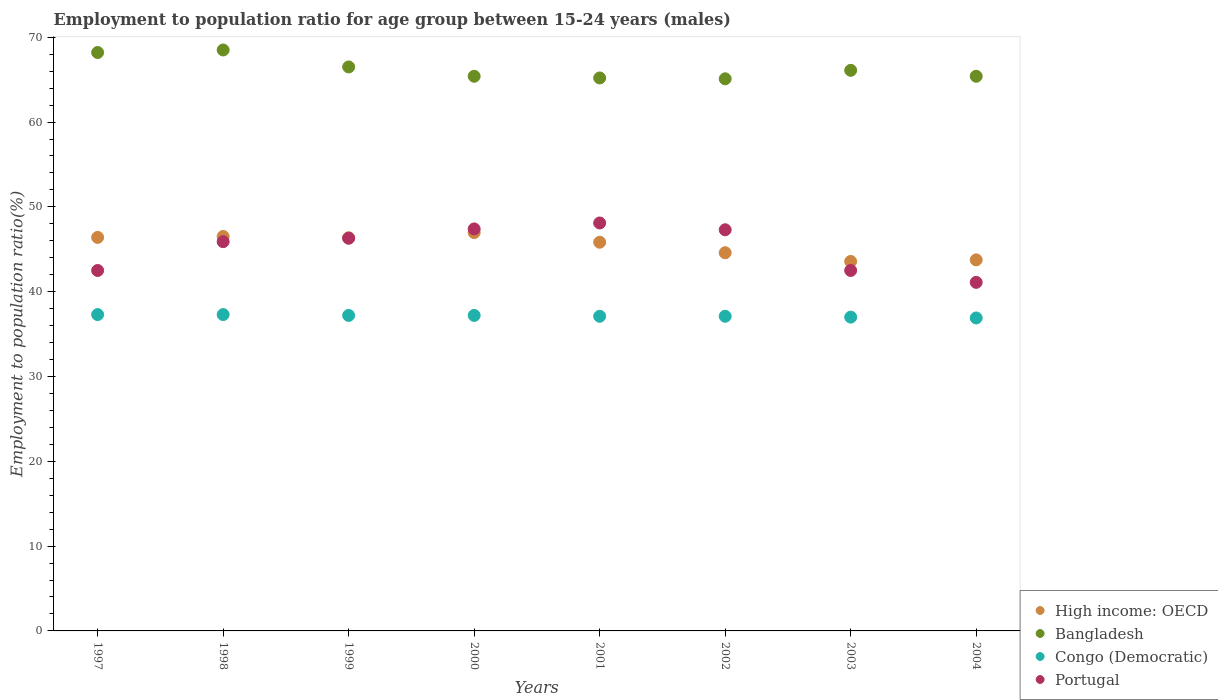What is the employment to population ratio in High income: OECD in 2004?
Your answer should be compact. 43.75. Across all years, what is the maximum employment to population ratio in Portugal?
Keep it short and to the point. 48.1. Across all years, what is the minimum employment to population ratio in Bangladesh?
Offer a very short reply. 65.1. What is the total employment to population ratio in Congo (Democratic) in the graph?
Your answer should be compact. 297.1. What is the difference between the employment to population ratio in Bangladesh in 2002 and that in 2004?
Your response must be concise. -0.3. What is the difference between the employment to population ratio in Portugal in 2002 and the employment to population ratio in High income: OECD in 1997?
Provide a short and direct response. 0.9. What is the average employment to population ratio in High income: OECD per year?
Provide a short and direct response. 45.5. In the year 2000, what is the difference between the employment to population ratio in High income: OECD and employment to population ratio in Congo (Democratic)?
Your answer should be very brief. 9.77. In how many years, is the employment to population ratio in Portugal greater than 26 %?
Provide a succinct answer. 8. What is the ratio of the employment to population ratio in Portugal in 1997 to that in 2000?
Your response must be concise. 0.9. What is the difference between the highest and the second highest employment to population ratio in Portugal?
Your answer should be compact. 0.7. What is the difference between the highest and the lowest employment to population ratio in Bangladesh?
Your answer should be compact. 3.4. Is the sum of the employment to population ratio in High income: OECD in 1998 and 1999 greater than the maximum employment to population ratio in Bangladesh across all years?
Your answer should be very brief. Yes. Does the employment to population ratio in High income: OECD monotonically increase over the years?
Provide a short and direct response. No. Is the employment to population ratio in High income: OECD strictly greater than the employment to population ratio in Bangladesh over the years?
Make the answer very short. No. How many years are there in the graph?
Ensure brevity in your answer.  8. What is the difference between two consecutive major ticks on the Y-axis?
Your answer should be compact. 10. Are the values on the major ticks of Y-axis written in scientific E-notation?
Offer a very short reply. No. Does the graph contain grids?
Your answer should be very brief. No. Where does the legend appear in the graph?
Keep it short and to the point. Bottom right. What is the title of the graph?
Make the answer very short. Employment to population ratio for age group between 15-24 years (males). What is the label or title of the Y-axis?
Your response must be concise. Employment to population ratio(%). What is the Employment to population ratio(%) in High income: OECD in 1997?
Offer a very short reply. 46.4. What is the Employment to population ratio(%) in Bangladesh in 1997?
Offer a very short reply. 68.2. What is the Employment to population ratio(%) in Congo (Democratic) in 1997?
Give a very brief answer. 37.3. What is the Employment to population ratio(%) in Portugal in 1997?
Your response must be concise. 42.5. What is the Employment to population ratio(%) in High income: OECD in 1998?
Ensure brevity in your answer.  46.51. What is the Employment to population ratio(%) in Bangladesh in 1998?
Offer a very short reply. 68.5. What is the Employment to population ratio(%) in Congo (Democratic) in 1998?
Your answer should be compact. 37.3. What is the Employment to population ratio(%) of Portugal in 1998?
Offer a terse response. 45.9. What is the Employment to population ratio(%) of High income: OECD in 1999?
Give a very brief answer. 46.36. What is the Employment to population ratio(%) in Bangladesh in 1999?
Offer a terse response. 66.5. What is the Employment to population ratio(%) in Congo (Democratic) in 1999?
Offer a very short reply. 37.2. What is the Employment to population ratio(%) of Portugal in 1999?
Your answer should be compact. 46.3. What is the Employment to population ratio(%) in High income: OECD in 2000?
Give a very brief answer. 46.97. What is the Employment to population ratio(%) of Bangladesh in 2000?
Give a very brief answer. 65.4. What is the Employment to population ratio(%) in Congo (Democratic) in 2000?
Keep it short and to the point. 37.2. What is the Employment to population ratio(%) in Portugal in 2000?
Your response must be concise. 47.4. What is the Employment to population ratio(%) in High income: OECD in 2001?
Your answer should be compact. 45.83. What is the Employment to population ratio(%) in Bangladesh in 2001?
Your answer should be very brief. 65.2. What is the Employment to population ratio(%) of Congo (Democratic) in 2001?
Your response must be concise. 37.1. What is the Employment to population ratio(%) of Portugal in 2001?
Your answer should be compact. 48.1. What is the Employment to population ratio(%) of High income: OECD in 2002?
Your response must be concise. 44.59. What is the Employment to population ratio(%) of Bangladesh in 2002?
Ensure brevity in your answer.  65.1. What is the Employment to population ratio(%) of Congo (Democratic) in 2002?
Offer a very short reply. 37.1. What is the Employment to population ratio(%) of Portugal in 2002?
Provide a short and direct response. 47.3. What is the Employment to population ratio(%) of High income: OECD in 2003?
Provide a succinct answer. 43.56. What is the Employment to population ratio(%) in Bangladesh in 2003?
Keep it short and to the point. 66.1. What is the Employment to population ratio(%) of Congo (Democratic) in 2003?
Ensure brevity in your answer.  37. What is the Employment to population ratio(%) in Portugal in 2003?
Make the answer very short. 42.5. What is the Employment to population ratio(%) of High income: OECD in 2004?
Give a very brief answer. 43.75. What is the Employment to population ratio(%) of Bangladesh in 2004?
Make the answer very short. 65.4. What is the Employment to population ratio(%) of Congo (Democratic) in 2004?
Provide a succinct answer. 36.9. What is the Employment to population ratio(%) of Portugal in 2004?
Provide a succinct answer. 41.1. Across all years, what is the maximum Employment to population ratio(%) in High income: OECD?
Provide a short and direct response. 46.97. Across all years, what is the maximum Employment to population ratio(%) of Bangladesh?
Make the answer very short. 68.5. Across all years, what is the maximum Employment to population ratio(%) of Congo (Democratic)?
Ensure brevity in your answer.  37.3. Across all years, what is the maximum Employment to population ratio(%) in Portugal?
Your response must be concise. 48.1. Across all years, what is the minimum Employment to population ratio(%) of High income: OECD?
Provide a short and direct response. 43.56. Across all years, what is the minimum Employment to population ratio(%) of Bangladesh?
Your answer should be compact. 65.1. Across all years, what is the minimum Employment to population ratio(%) in Congo (Democratic)?
Provide a succinct answer. 36.9. Across all years, what is the minimum Employment to population ratio(%) of Portugal?
Ensure brevity in your answer.  41.1. What is the total Employment to population ratio(%) in High income: OECD in the graph?
Ensure brevity in your answer.  363.98. What is the total Employment to population ratio(%) of Bangladesh in the graph?
Provide a short and direct response. 530.4. What is the total Employment to population ratio(%) in Congo (Democratic) in the graph?
Keep it short and to the point. 297.1. What is the total Employment to population ratio(%) in Portugal in the graph?
Your response must be concise. 361.1. What is the difference between the Employment to population ratio(%) in High income: OECD in 1997 and that in 1998?
Make the answer very short. -0.11. What is the difference between the Employment to population ratio(%) in Bangladesh in 1997 and that in 1998?
Provide a succinct answer. -0.3. What is the difference between the Employment to population ratio(%) in Congo (Democratic) in 1997 and that in 1998?
Provide a short and direct response. 0. What is the difference between the Employment to population ratio(%) in High income: OECD in 1997 and that in 1999?
Offer a very short reply. 0.04. What is the difference between the Employment to population ratio(%) in Congo (Democratic) in 1997 and that in 1999?
Your response must be concise. 0.1. What is the difference between the Employment to population ratio(%) in High income: OECD in 1997 and that in 2000?
Offer a very short reply. -0.57. What is the difference between the Employment to population ratio(%) of Bangladesh in 1997 and that in 2000?
Provide a succinct answer. 2.8. What is the difference between the Employment to population ratio(%) in Portugal in 1997 and that in 2000?
Ensure brevity in your answer.  -4.9. What is the difference between the Employment to population ratio(%) in High income: OECD in 1997 and that in 2001?
Your answer should be compact. 0.57. What is the difference between the Employment to population ratio(%) in Bangladesh in 1997 and that in 2001?
Your response must be concise. 3. What is the difference between the Employment to population ratio(%) in Congo (Democratic) in 1997 and that in 2001?
Your answer should be very brief. 0.2. What is the difference between the Employment to population ratio(%) of Portugal in 1997 and that in 2001?
Your answer should be compact. -5.6. What is the difference between the Employment to population ratio(%) of High income: OECD in 1997 and that in 2002?
Give a very brief answer. 1.81. What is the difference between the Employment to population ratio(%) of Bangladesh in 1997 and that in 2002?
Provide a short and direct response. 3.1. What is the difference between the Employment to population ratio(%) of Congo (Democratic) in 1997 and that in 2002?
Provide a short and direct response. 0.2. What is the difference between the Employment to population ratio(%) in High income: OECD in 1997 and that in 2003?
Make the answer very short. 2.84. What is the difference between the Employment to population ratio(%) in High income: OECD in 1997 and that in 2004?
Your answer should be very brief. 2.65. What is the difference between the Employment to population ratio(%) of High income: OECD in 1998 and that in 1999?
Make the answer very short. 0.15. What is the difference between the Employment to population ratio(%) in Portugal in 1998 and that in 1999?
Provide a succinct answer. -0.4. What is the difference between the Employment to population ratio(%) in High income: OECD in 1998 and that in 2000?
Make the answer very short. -0.46. What is the difference between the Employment to population ratio(%) of Bangladesh in 1998 and that in 2000?
Provide a short and direct response. 3.1. What is the difference between the Employment to population ratio(%) of Portugal in 1998 and that in 2000?
Offer a very short reply. -1.5. What is the difference between the Employment to population ratio(%) of High income: OECD in 1998 and that in 2001?
Your response must be concise. 0.68. What is the difference between the Employment to population ratio(%) in Congo (Democratic) in 1998 and that in 2001?
Provide a short and direct response. 0.2. What is the difference between the Employment to population ratio(%) in High income: OECD in 1998 and that in 2002?
Provide a succinct answer. 1.92. What is the difference between the Employment to population ratio(%) in Congo (Democratic) in 1998 and that in 2002?
Your answer should be very brief. 0.2. What is the difference between the Employment to population ratio(%) in Portugal in 1998 and that in 2002?
Your answer should be very brief. -1.4. What is the difference between the Employment to population ratio(%) in High income: OECD in 1998 and that in 2003?
Keep it short and to the point. 2.95. What is the difference between the Employment to population ratio(%) of Congo (Democratic) in 1998 and that in 2003?
Your answer should be compact. 0.3. What is the difference between the Employment to population ratio(%) of Portugal in 1998 and that in 2003?
Keep it short and to the point. 3.4. What is the difference between the Employment to population ratio(%) in High income: OECD in 1998 and that in 2004?
Your answer should be very brief. 2.76. What is the difference between the Employment to population ratio(%) of Congo (Democratic) in 1998 and that in 2004?
Your response must be concise. 0.4. What is the difference between the Employment to population ratio(%) of High income: OECD in 1999 and that in 2000?
Your answer should be compact. -0.61. What is the difference between the Employment to population ratio(%) of Bangladesh in 1999 and that in 2000?
Your answer should be compact. 1.1. What is the difference between the Employment to population ratio(%) of Portugal in 1999 and that in 2000?
Provide a succinct answer. -1.1. What is the difference between the Employment to population ratio(%) in High income: OECD in 1999 and that in 2001?
Your answer should be compact. 0.53. What is the difference between the Employment to population ratio(%) in Congo (Democratic) in 1999 and that in 2001?
Ensure brevity in your answer.  0.1. What is the difference between the Employment to population ratio(%) in Portugal in 1999 and that in 2001?
Keep it short and to the point. -1.8. What is the difference between the Employment to population ratio(%) in High income: OECD in 1999 and that in 2002?
Ensure brevity in your answer.  1.77. What is the difference between the Employment to population ratio(%) in Bangladesh in 1999 and that in 2002?
Offer a terse response. 1.4. What is the difference between the Employment to population ratio(%) in Congo (Democratic) in 1999 and that in 2002?
Provide a short and direct response. 0.1. What is the difference between the Employment to population ratio(%) in Portugal in 1999 and that in 2002?
Provide a succinct answer. -1. What is the difference between the Employment to population ratio(%) of High income: OECD in 1999 and that in 2003?
Your answer should be very brief. 2.79. What is the difference between the Employment to population ratio(%) in Congo (Democratic) in 1999 and that in 2003?
Offer a very short reply. 0.2. What is the difference between the Employment to population ratio(%) in Portugal in 1999 and that in 2003?
Your answer should be compact. 3.8. What is the difference between the Employment to population ratio(%) in High income: OECD in 1999 and that in 2004?
Your answer should be very brief. 2.61. What is the difference between the Employment to population ratio(%) of Congo (Democratic) in 1999 and that in 2004?
Provide a short and direct response. 0.3. What is the difference between the Employment to population ratio(%) in Portugal in 1999 and that in 2004?
Make the answer very short. 5.2. What is the difference between the Employment to population ratio(%) in High income: OECD in 2000 and that in 2001?
Your answer should be compact. 1.14. What is the difference between the Employment to population ratio(%) of Congo (Democratic) in 2000 and that in 2001?
Keep it short and to the point. 0.1. What is the difference between the Employment to population ratio(%) in High income: OECD in 2000 and that in 2002?
Your response must be concise. 2.38. What is the difference between the Employment to population ratio(%) in Bangladesh in 2000 and that in 2002?
Ensure brevity in your answer.  0.3. What is the difference between the Employment to population ratio(%) in Congo (Democratic) in 2000 and that in 2002?
Your answer should be very brief. 0.1. What is the difference between the Employment to population ratio(%) in Portugal in 2000 and that in 2002?
Provide a succinct answer. 0.1. What is the difference between the Employment to population ratio(%) of High income: OECD in 2000 and that in 2003?
Give a very brief answer. 3.4. What is the difference between the Employment to population ratio(%) in Portugal in 2000 and that in 2003?
Offer a very short reply. 4.9. What is the difference between the Employment to population ratio(%) in High income: OECD in 2000 and that in 2004?
Offer a terse response. 3.22. What is the difference between the Employment to population ratio(%) in Bangladesh in 2000 and that in 2004?
Ensure brevity in your answer.  0. What is the difference between the Employment to population ratio(%) in Congo (Democratic) in 2000 and that in 2004?
Ensure brevity in your answer.  0.3. What is the difference between the Employment to population ratio(%) of Portugal in 2000 and that in 2004?
Your response must be concise. 6.3. What is the difference between the Employment to population ratio(%) of High income: OECD in 2001 and that in 2002?
Offer a very short reply. 1.24. What is the difference between the Employment to population ratio(%) in Congo (Democratic) in 2001 and that in 2002?
Your answer should be very brief. 0. What is the difference between the Employment to population ratio(%) of High income: OECD in 2001 and that in 2003?
Offer a very short reply. 2.27. What is the difference between the Employment to population ratio(%) in Bangladesh in 2001 and that in 2003?
Provide a succinct answer. -0.9. What is the difference between the Employment to population ratio(%) of Congo (Democratic) in 2001 and that in 2003?
Your answer should be very brief. 0.1. What is the difference between the Employment to population ratio(%) of High income: OECD in 2001 and that in 2004?
Your answer should be very brief. 2.08. What is the difference between the Employment to population ratio(%) in Bangladesh in 2001 and that in 2004?
Ensure brevity in your answer.  -0.2. What is the difference between the Employment to population ratio(%) of Congo (Democratic) in 2001 and that in 2004?
Provide a short and direct response. 0.2. What is the difference between the Employment to population ratio(%) in Portugal in 2001 and that in 2004?
Ensure brevity in your answer.  7. What is the difference between the Employment to population ratio(%) in High income: OECD in 2002 and that in 2003?
Ensure brevity in your answer.  1.03. What is the difference between the Employment to population ratio(%) of Congo (Democratic) in 2002 and that in 2003?
Provide a succinct answer. 0.1. What is the difference between the Employment to population ratio(%) of Portugal in 2002 and that in 2003?
Your answer should be compact. 4.8. What is the difference between the Employment to population ratio(%) in High income: OECD in 2002 and that in 2004?
Your answer should be very brief. 0.84. What is the difference between the Employment to population ratio(%) in Bangladesh in 2002 and that in 2004?
Give a very brief answer. -0.3. What is the difference between the Employment to population ratio(%) in High income: OECD in 2003 and that in 2004?
Your answer should be very brief. -0.19. What is the difference between the Employment to population ratio(%) in Congo (Democratic) in 2003 and that in 2004?
Keep it short and to the point. 0.1. What is the difference between the Employment to population ratio(%) of Portugal in 2003 and that in 2004?
Ensure brevity in your answer.  1.4. What is the difference between the Employment to population ratio(%) of High income: OECD in 1997 and the Employment to population ratio(%) of Bangladesh in 1998?
Offer a very short reply. -22.1. What is the difference between the Employment to population ratio(%) in High income: OECD in 1997 and the Employment to population ratio(%) in Congo (Democratic) in 1998?
Provide a short and direct response. 9.1. What is the difference between the Employment to population ratio(%) in High income: OECD in 1997 and the Employment to population ratio(%) in Portugal in 1998?
Make the answer very short. 0.5. What is the difference between the Employment to population ratio(%) in Bangladesh in 1997 and the Employment to population ratio(%) in Congo (Democratic) in 1998?
Offer a very short reply. 30.9. What is the difference between the Employment to population ratio(%) in Bangladesh in 1997 and the Employment to population ratio(%) in Portugal in 1998?
Offer a very short reply. 22.3. What is the difference between the Employment to population ratio(%) of High income: OECD in 1997 and the Employment to population ratio(%) of Bangladesh in 1999?
Your response must be concise. -20.1. What is the difference between the Employment to population ratio(%) of High income: OECD in 1997 and the Employment to population ratio(%) of Congo (Democratic) in 1999?
Make the answer very short. 9.2. What is the difference between the Employment to population ratio(%) of High income: OECD in 1997 and the Employment to population ratio(%) of Portugal in 1999?
Your response must be concise. 0.1. What is the difference between the Employment to population ratio(%) of Bangladesh in 1997 and the Employment to population ratio(%) of Congo (Democratic) in 1999?
Give a very brief answer. 31. What is the difference between the Employment to population ratio(%) of Bangladesh in 1997 and the Employment to population ratio(%) of Portugal in 1999?
Offer a terse response. 21.9. What is the difference between the Employment to population ratio(%) in High income: OECD in 1997 and the Employment to population ratio(%) in Bangladesh in 2000?
Give a very brief answer. -19. What is the difference between the Employment to population ratio(%) in High income: OECD in 1997 and the Employment to population ratio(%) in Congo (Democratic) in 2000?
Make the answer very short. 9.2. What is the difference between the Employment to population ratio(%) of High income: OECD in 1997 and the Employment to population ratio(%) of Portugal in 2000?
Make the answer very short. -1. What is the difference between the Employment to population ratio(%) of Bangladesh in 1997 and the Employment to population ratio(%) of Portugal in 2000?
Give a very brief answer. 20.8. What is the difference between the Employment to population ratio(%) of Congo (Democratic) in 1997 and the Employment to population ratio(%) of Portugal in 2000?
Provide a succinct answer. -10.1. What is the difference between the Employment to population ratio(%) of High income: OECD in 1997 and the Employment to population ratio(%) of Bangladesh in 2001?
Give a very brief answer. -18.8. What is the difference between the Employment to population ratio(%) of High income: OECD in 1997 and the Employment to population ratio(%) of Congo (Democratic) in 2001?
Your answer should be very brief. 9.3. What is the difference between the Employment to population ratio(%) in High income: OECD in 1997 and the Employment to population ratio(%) in Portugal in 2001?
Offer a very short reply. -1.7. What is the difference between the Employment to population ratio(%) of Bangladesh in 1997 and the Employment to population ratio(%) of Congo (Democratic) in 2001?
Provide a short and direct response. 31.1. What is the difference between the Employment to population ratio(%) of Bangladesh in 1997 and the Employment to population ratio(%) of Portugal in 2001?
Your answer should be very brief. 20.1. What is the difference between the Employment to population ratio(%) of Congo (Democratic) in 1997 and the Employment to population ratio(%) of Portugal in 2001?
Your answer should be compact. -10.8. What is the difference between the Employment to population ratio(%) of High income: OECD in 1997 and the Employment to population ratio(%) of Bangladesh in 2002?
Provide a succinct answer. -18.7. What is the difference between the Employment to population ratio(%) in High income: OECD in 1997 and the Employment to population ratio(%) in Congo (Democratic) in 2002?
Offer a very short reply. 9.3. What is the difference between the Employment to population ratio(%) of High income: OECD in 1997 and the Employment to population ratio(%) of Portugal in 2002?
Make the answer very short. -0.9. What is the difference between the Employment to population ratio(%) in Bangladesh in 1997 and the Employment to population ratio(%) in Congo (Democratic) in 2002?
Keep it short and to the point. 31.1. What is the difference between the Employment to population ratio(%) of Bangladesh in 1997 and the Employment to population ratio(%) of Portugal in 2002?
Provide a short and direct response. 20.9. What is the difference between the Employment to population ratio(%) in High income: OECD in 1997 and the Employment to population ratio(%) in Bangladesh in 2003?
Make the answer very short. -19.7. What is the difference between the Employment to population ratio(%) in High income: OECD in 1997 and the Employment to population ratio(%) in Congo (Democratic) in 2003?
Your answer should be very brief. 9.4. What is the difference between the Employment to population ratio(%) of High income: OECD in 1997 and the Employment to population ratio(%) of Portugal in 2003?
Your answer should be very brief. 3.9. What is the difference between the Employment to population ratio(%) of Bangladesh in 1997 and the Employment to population ratio(%) of Congo (Democratic) in 2003?
Offer a very short reply. 31.2. What is the difference between the Employment to population ratio(%) of Bangladesh in 1997 and the Employment to population ratio(%) of Portugal in 2003?
Offer a very short reply. 25.7. What is the difference between the Employment to population ratio(%) of High income: OECD in 1997 and the Employment to population ratio(%) of Bangladesh in 2004?
Offer a terse response. -19. What is the difference between the Employment to population ratio(%) of High income: OECD in 1997 and the Employment to population ratio(%) of Congo (Democratic) in 2004?
Ensure brevity in your answer.  9.5. What is the difference between the Employment to population ratio(%) of High income: OECD in 1997 and the Employment to population ratio(%) of Portugal in 2004?
Give a very brief answer. 5.3. What is the difference between the Employment to population ratio(%) in Bangladesh in 1997 and the Employment to population ratio(%) in Congo (Democratic) in 2004?
Offer a terse response. 31.3. What is the difference between the Employment to population ratio(%) of Bangladesh in 1997 and the Employment to population ratio(%) of Portugal in 2004?
Make the answer very short. 27.1. What is the difference between the Employment to population ratio(%) in High income: OECD in 1998 and the Employment to population ratio(%) in Bangladesh in 1999?
Give a very brief answer. -19.99. What is the difference between the Employment to population ratio(%) of High income: OECD in 1998 and the Employment to population ratio(%) of Congo (Democratic) in 1999?
Your answer should be compact. 9.31. What is the difference between the Employment to population ratio(%) in High income: OECD in 1998 and the Employment to population ratio(%) in Portugal in 1999?
Provide a short and direct response. 0.21. What is the difference between the Employment to population ratio(%) of Bangladesh in 1998 and the Employment to population ratio(%) of Congo (Democratic) in 1999?
Keep it short and to the point. 31.3. What is the difference between the Employment to population ratio(%) of Bangladesh in 1998 and the Employment to population ratio(%) of Portugal in 1999?
Your response must be concise. 22.2. What is the difference between the Employment to population ratio(%) in High income: OECD in 1998 and the Employment to population ratio(%) in Bangladesh in 2000?
Offer a terse response. -18.89. What is the difference between the Employment to population ratio(%) in High income: OECD in 1998 and the Employment to population ratio(%) in Congo (Democratic) in 2000?
Offer a very short reply. 9.31. What is the difference between the Employment to population ratio(%) in High income: OECD in 1998 and the Employment to population ratio(%) in Portugal in 2000?
Your answer should be very brief. -0.89. What is the difference between the Employment to population ratio(%) of Bangladesh in 1998 and the Employment to population ratio(%) of Congo (Democratic) in 2000?
Ensure brevity in your answer.  31.3. What is the difference between the Employment to population ratio(%) of Bangladesh in 1998 and the Employment to population ratio(%) of Portugal in 2000?
Offer a terse response. 21.1. What is the difference between the Employment to population ratio(%) of Congo (Democratic) in 1998 and the Employment to population ratio(%) of Portugal in 2000?
Provide a succinct answer. -10.1. What is the difference between the Employment to population ratio(%) of High income: OECD in 1998 and the Employment to population ratio(%) of Bangladesh in 2001?
Provide a succinct answer. -18.69. What is the difference between the Employment to population ratio(%) of High income: OECD in 1998 and the Employment to population ratio(%) of Congo (Democratic) in 2001?
Your answer should be very brief. 9.41. What is the difference between the Employment to population ratio(%) in High income: OECD in 1998 and the Employment to population ratio(%) in Portugal in 2001?
Keep it short and to the point. -1.59. What is the difference between the Employment to population ratio(%) of Bangladesh in 1998 and the Employment to population ratio(%) of Congo (Democratic) in 2001?
Provide a short and direct response. 31.4. What is the difference between the Employment to population ratio(%) in Bangladesh in 1998 and the Employment to population ratio(%) in Portugal in 2001?
Make the answer very short. 20.4. What is the difference between the Employment to population ratio(%) in High income: OECD in 1998 and the Employment to population ratio(%) in Bangladesh in 2002?
Keep it short and to the point. -18.59. What is the difference between the Employment to population ratio(%) in High income: OECD in 1998 and the Employment to population ratio(%) in Congo (Democratic) in 2002?
Provide a succinct answer. 9.41. What is the difference between the Employment to population ratio(%) of High income: OECD in 1998 and the Employment to population ratio(%) of Portugal in 2002?
Make the answer very short. -0.79. What is the difference between the Employment to population ratio(%) in Bangladesh in 1998 and the Employment to population ratio(%) in Congo (Democratic) in 2002?
Your response must be concise. 31.4. What is the difference between the Employment to population ratio(%) in Bangladesh in 1998 and the Employment to population ratio(%) in Portugal in 2002?
Ensure brevity in your answer.  21.2. What is the difference between the Employment to population ratio(%) of Congo (Democratic) in 1998 and the Employment to population ratio(%) of Portugal in 2002?
Your answer should be very brief. -10. What is the difference between the Employment to population ratio(%) in High income: OECD in 1998 and the Employment to population ratio(%) in Bangladesh in 2003?
Offer a very short reply. -19.59. What is the difference between the Employment to population ratio(%) in High income: OECD in 1998 and the Employment to population ratio(%) in Congo (Democratic) in 2003?
Keep it short and to the point. 9.51. What is the difference between the Employment to population ratio(%) of High income: OECD in 1998 and the Employment to population ratio(%) of Portugal in 2003?
Your answer should be compact. 4.01. What is the difference between the Employment to population ratio(%) in Bangladesh in 1998 and the Employment to population ratio(%) in Congo (Democratic) in 2003?
Keep it short and to the point. 31.5. What is the difference between the Employment to population ratio(%) of High income: OECD in 1998 and the Employment to population ratio(%) of Bangladesh in 2004?
Your response must be concise. -18.89. What is the difference between the Employment to population ratio(%) in High income: OECD in 1998 and the Employment to population ratio(%) in Congo (Democratic) in 2004?
Your answer should be very brief. 9.61. What is the difference between the Employment to population ratio(%) in High income: OECD in 1998 and the Employment to population ratio(%) in Portugal in 2004?
Your answer should be compact. 5.41. What is the difference between the Employment to population ratio(%) in Bangladesh in 1998 and the Employment to population ratio(%) in Congo (Democratic) in 2004?
Offer a very short reply. 31.6. What is the difference between the Employment to population ratio(%) of Bangladesh in 1998 and the Employment to population ratio(%) of Portugal in 2004?
Offer a terse response. 27.4. What is the difference between the Employment to population ratio(%) of High income: OECD in 1999 and the Employment to population ratio(%) of Bangladesh in 2000?
Make the answer very short. -19.04. What is the difference between the Employment to population ratio(%) in High income: OECD in 1999 and the Employment to population ratio(%) in Congo (Democratic) in 2000?
Make the answer very short. 9.16. What is the difference between the Employment to population ratio(%) in High income: OECD in 1999 and the Employment to population ratio(%) in Portugal in 2000?
Your response must be concise. -1.04. What is the difference between the Employment to population ratio(%) in Bangladesh in 1999 and the Employment to population ratio(%) in Congo (Democratic) in 2000?
Provide a succinct answer. 29.3. What is the difference between the Employment to population ratio(%) in Bangladesh in 1999 and the Employment to population ratio(%) in Portugal in 2000?
Make the answer very short. 19.1. What is the difference between the Employment to population ratio(%) of High income: OECD in 1999 and the Employment to population ratio(%) of Bangladesh in 2001?
Provide a succinct answer. -18.84. What is the difference between the Employment to population ratio(%) in High income: OECD in 1999 and the Employment to population ratio(%) in Congo (Democratic) in 2001?
Keep it short and to the point. 9.26. What is the difference between the Employment to population ratio(%) in High income: OECD in 1999 and the Employment to population ratio(%) in Portugal in 2001?
Provide a succinct answer. -1.74. What is the difference between the Employment to population ratio(%) of Bangladesh in 1999 and the Employment to population ratio(%) of Congo (Democratic) in 2001?
Offer a terse response. 29.4. What is the difference between the Employment to population ratio(%) of High income: OECD in 1999 and the Employment to population ratio(%) of Bangladesh in 2002?
Your answer should be very brief. -18.74. What is the difference between the Employment to population ratio(%) in High income: OECD in 1999 and the Employment to population ratio(%) in Congo (Democratic) in 2002?
Offer a very short reply. 9.26. What is the difference between the Employment to population ratio(%) in High income: OECD in 1999 and the Employment to population ratio(%) in Portugal in 2002?
Offer a terse response. -0.94. What is the difference between the Employment to population ratio(%) of Bangladesh in 1999 and the Employment to population ratio(%) of Congo (Democratic) in 2002?
Offer a very short reply. 29.4. What is the difference between the Employment to population ratio(%) in High income: OECD in 1999 and the Employment to population ratio(%) in Bangladesh in 2003?
Provide a short and direct response. -19.74. What is the difference between the Employment to population ratio(%) of High income: OECD in 1999 and the Employment to population ratio(%) of Congo (Democratic) in 2003?
Offer a very short reply. 9.36. What is the difference between the Employment to population ratio(%) of High income: OECD in 1999 and the Employment to population ratio(%) of Portugal in 2003?
Offer a very short reply. 3.86. What is the difference between the Employment to population ratio(%) in Bangladesh in 1999 and the Employment to population ratio(%) in Congo (Democratic) in 2003?
Your response must be concise. 29.5. What is the difference between the Employment to population ratio(%) in Congo (Democratic) in 1999 and the Employment to population ratio(%) in Portugal in 2003?
Your answer should be compact. -5.3. What is the difference between the Employment to population ratio(%) in High income: OECD in 1999 and the Employment to population ratio(%) in Bangladesh in 2004?
Offer a terse response. -19.04. What is the difference between the Employment to population ratio(%) of High income: OECD in 1999 and the Employment to population ratio(%) of Congo (Democratic) in 2004?
Provide a succinct answer. 9.46. What is the difference between the Employment to population ratio(%) of High income: OECD in 1999 and the Employment to population ratio(%) of Portugal in 2004?
Give a very brief answer. 5.26. What is the difference between the Employment to population ratio(%) in Bangladesh in 1999 and the Employment to population ratio(%) in Congo (Democratic) in 2004?
Offer a very short reply. 29.6. What is the difference between the Employment to population ratio(%) of Bangladesh in 1999 and the Employment to population ratio(%) of Portugal in 2004?
Give a very brief answer. 25.4. What is the difference between the Employment to population ratio(%) in High income: OECD in 2000 and the Employment to population ratio(%) in Bangladesh in 2001?
Make the answer very short. -18.23. What is the difference between the Employment to population ratio(%) in High income: OECD in 2000 and the Employment to population ratio(%) in Congo (Democratic) in 2001?
Give a very brief answer. 9.87. What is the difference between the Employment to population ratio(%) in High income: OECD in 2000 and the Employment to population ratio(%) in Portugal in 2001?
Provide a succinct answer. -1.13. What is the difference between the Employment to population ratio(%) in Bangladesh in 2000 and the Employment to population ratio(%) in Congo (Democratic) in 2001?
Your response must be concise. 28.3. What is the difference between the Employment to population ratio(%) of Bangladesh in 2000 and the Employment to population ratio(%) of Portugal in 2001?
Offer a terse response. 17.3. What is the difference between the Employment to population ratio(%) in High income: OECD in 2000 and the Employment to population ratio(%) in Bangladesh in 2002?
Your answer should be very brief. -18.13. What is the difference between the Employment to population ratio(%) of High income: OECD in 2000 and the Employment to population ratio(%) of Congo (Democratic) in 2002?
Ensure brevity in your answer.  9.87. What is the difference between the Employment to population ratio(%) of High income: OECD in 2000 and the Employment to population ratio(%) of Portugal in 2002?
Make the answer very short. -0.33. What is the difference between the Employment to population ratio(%) of Bangladesh in 2000 and the Employment to population ratio(%) of Congo (Democratic) in 2002?
Your response must be concise. 28.3. What is the difference between the Employment to population ratio(%) of Bangladesh in 2000 and the Employment to population ratio(%) of Portugal in 2002?
Your answer should be compact. 18.1. What is the difference between the Employment to population ratio(%) of High income: OECD in 2000 and the Employment to population ratio(%) of Bangladesh in 2003?
Provide a succinct answer. -19.13. What is the difference between the Employment to population ratio(%) in High income: OECD in 2000 and the Employment to population ratio(%) in Congo (Democratic) in 2003?
Offer a very short reply. 9.97. What is the difference between the Employment to population ratio(%) of High income: OECD in 2000 and the Employment to population ratio(%) of Portugal in 2003?
Provide a succinct answer. 4.47. What is the difference between the Employment to population ratio(%) in Bangladesh in 2000 and the Employment to population ratio(%) in Congo (Democratic) in 2003?
Keep it short and to the point. 28.4. What is the difference between the Employment to population ratio(%) in Bangladesh in 2000 and the Employment to population ratio(%) in Portugal in 2003?
Make the answer very short. 22.9. What is the difference between the Employment to population ratio(%) of Congo (Democratic) in 2000 and the Employment to population ratio(%) of Portugal in 2003?
Your answer should be very brief. -5.3. What is the difference between the Employment to population ratio(%) of High income: OECD in 2000 and the Employment to population ratio(%) of Bangladesh in 2004?
Offer a very short reply. -18.43. What is the difference between the Employment to population ratio(%) in High income: OECD in 2000 and the Employment to population ratio(%) in Congo (Democratic) in 2004?
Your response must be concise. 10.07. What is the difference between the Employment to population ratio(%) in High income: OECD in 2000 and the Employment to population ratio(%) in Portugal in 2004?
Your answer should be compact. 5.87. What is the difference between the Employment to population ratio(%) of Bangladesh in 2000 and the Employment to population ratio(%) of Portugal in 2004?
Ensure brevity in your answer.  24.3. What is the difference between the Employment to population ratio(%) in Congo (Democratic) in 2000 and the Employment to population ratio(%) in Portugal in 2004?
Give a very brief answer. -3.9. What is the difference between the Employment to population ratio(%) in High income: OECD in 2001 and the Employment to population ratio(%) in Bangladesh in 2002?
Your answer should be compact. -19.27. What is the difference between the Employment to population ratio(%) in High income: OECD in 2001 and the Employment to population ratio(%) in Congo (Democratic) in 2002?
Offer a terse response. 8.73. What is the difference between the Employment to population ratio(%) in High income: OECD in 2001 and the Employment to population ratio(%) in Portugal in 2002?
Your response must be concise. -1.47. What is the difference between the Employment to population ratio(%) in Bangladesh in 2001 and the Employment to population ratio(%) in Congo (Democratic) in 2002?
Ensure brevity in your answer.  28.1. What is the difference between the Employment to population ratio(%) in High income: OECD in 2001 and the Employment to population ratio(%) in Bangladesh in 2003?
Your answer should be very brief. -20.27. What is the difference between the Employment to population ratio(%) in High income: OECD in 2001 and the Employment to population ratio(%) in Congo (Democratic) in 2003?
Give a very brief answer. 8.83. What is the difference between the Employment to population ratio(%) of High income: OECD in 2001 and the Employment to population ratio(%) of Portugal in 2003?
Provide a succinct answer. 3.33. What is the difference between the Employment to population ratio(%) in Bangladesh in 2001 and the Employment to population ratio(%) in Congo (Democratic) in 2003?
Your response must be concise. 28.2. What is the difference between the Employment to population ratio(%) of Bangladesh in 2001 and the Employment to population ratio(%) of Portugal in 2003?
Provide a succinct answer. 22.7. What is the difference between the Employment to population ratio(%) in High income: OECD in 2001 and the Employment to population ratio(%) in Bangladesh in 2004?
Make the answer very short. -19.57. What is the difference between the Employment to population ratio(%) in High income: OECD in 2001 and the Employment to population ratio(%) in Congo (Democratic) in 2004?
Offer a very short reply. 8.93. What is the difference between the Employment to population ratio(%) in High income: OECD in 2001 and the Employment to population ratio(%) in Portugal in 2004?
Keep it short and to the point. 4.73. What is the difference between the Employment to population ratio(%) of Bangladesh in 2001 and the Employment to population ratio(%) of Congo (Democratic) in 2004?
Your response must be concise. 28.3. What is the difference between the Employment to population ratio(%) of Bangladesh in 2001 and the Employment to population ratio(%) of Portugal in 2004?
Your response must be concise. 24.1. What is the difference between the Employment to population ratio(%) of High income: OECD in 2002 and the Employment to population ratio(%) of Bangladesh in 2003?
Your response must be concise. -21.51. What is the difference between the Employment to population ratio(%) of High income: OECD in 2002 and the Employment to population ratio(%) of Congo (Democratic) in 2003?
Your answer should be very brief. 7.59. What is the difference between the Employment to population ratio(%) of High income: OECD in 2002 and the Employment to population ratio(%) of Portugal in 2003?
Your answer should be very brief. 2.09. What is the difference between the Employment to population ratio(%) in Bangladesh in 2002 and the Employment to population ratio(%) in Congo (Democratic) in 2003?
Provide a succinct answer. 28.1. What is the difference between the Employment to population ratio(%) in Bangladesh in 2002 and the Employment to population ratio(%) in Portugal in 2003?
Your response must be concise. 22.6. What is the difference between the Employment to population ratio(%) in Congo (Democratic) in 2002 and the Employment to population ratio(%) in Portugal in 2003?
Ensure brevity in your answer.  -5.4. What is the difference between the Employment to population ratio(%) of High income: OECD in 2002 and the Employment to population ratio(%) of Bangladesh in 2004?
Your answer should be very brief. -20.81. What is the difference between the Employment to population ratio(%) of High income: OECD in 2002 and the Employment to population ratio(%) of Congo (Democratic) in 2004?
Your answer should be very brief. 7.69. What is the difference between the Employment to population ratio(%) of High income: OECD in 2002 and the Employment to population ratio(%) of Portugal in 2004?
Provide a short and direct response. 3.49. What is the difference between the Employment to population ratio(%) of Bangladesh in 2002 and the Employment to population ratio(%) of Congo (Democratic) in 2004?
Give a very brief answer. 28.2. What is the difference between the Employment to population ratio(%) of Congo (Democratic) in 2002 and the Employment to population ratio(%) of Portugal in 2004?
Make the answer very short. -4. What is the difference between the Employment to population ratio(%) in High income: OECD in 2003 and the Employment to population ratio(%) in Bangladesh in 2004?
Ensure brevity in your answer.  -21.84. What is the difference between the Employment to population ratio(%) in High income: OECD in 2003 and the Employment to population ratio(%) in Congo (Democratic) in 2004?
Provide a succinct answer. 6.66. What is the difference between the Employment to population ratio(%) of High income: OECD in 2003 and the Employment to population ratio(%) of Portugal in 2004?
Offer a very short reply. 2.46. What is the difference between the Employment to population ratio(%) in Bangladesh in 2003 and the Employment to population ratio(%) in Congo (Democratic) in 2004?
Provide a short and direct response. 29.2. What is the difference between the Employment to population ratio(%) of Bangladesh in 2003 and the Employment to population ratio(%) of Portugal in 2004?
Provide a short and direct response. 25. What is the difference between the Employment to population ratio(%) in Congo (Democratic) in 2003 and the Employment to population ratio(%) in Portugal in 2004?
Your answer should be very brief. -4.1. What is the average Employment to population ratio(%) of High income: OECD per year?
Your answer should be very brief. 45.5. What is the average Employment to population ratio(%) of Bangladesh per year?
Give a very brief answer. 66.3. What is the average Employment to population ratio(%) of Congo (Democratic) per year?
Offer a terse response. 37.14. What is the average Employment to population ratio(%) in Portugal per year?
Your response must be concise. 45.14. In the year 1997, what is the difference between the Employment to population ratio(%) of High income: OECD and Employment to population ratio(%) of Bangladesh?
Your response must be concise. -21.8. In the year 1997, what is the difference between the Employment to population ratio(%) of High income: OECD and Employment to population ratio(%) of Congo (Democratic)?
Keep it short and to the point. 9.1. In the year 1997, what is the difference between the Employment to population ratio(%) of High income: OECD and Employment to population ratio(%) of Portugal?
Your answer should be very brief. 3.9. In the year 1997, what is the difference between the Employment to population ratio(%) in Bangladesh and Employment to population ratio(%) in Congo (Democratic)?
Offer a very short reply. 30.9. In the year 1997, what is the difference between the Employment to population ratio(%) of Bangladesh and Employment to population ratio(%) of Portugal?
Provide a succinct answer. 25.7. In the year 1998, what is the difference between the Employment to population ratio(%) of High income: OECD and Employment to population ratio(%) of Bangladesh?
Keep it short and to the point. -21.99. In the year 1998, what is the difference between the Employment to population ratio(%) of High income: OECD and Employment to population ratio(%) of Congo (Democratic)?
Keep it short and to the point. 9.21. In the year 1998, what is the difference between the Employment to population ratio(%) in High income: OECD and Employment to population ratio(%) in Portugal?
Your answer should be compact. 0.61. In the year 1998, what is the difference between the Employment to population ratio(%) of Bangladesh and Employment to population ratio(%) of Congo (Democratic)?
Make the answer very short. 31.2. In the year 1998, what is the difference between the Employment to population ratio(%) in Bangladesh and Employment to population ratio(%) in Portugal?
Offer a very short reply. 22.6. In the year 1999, what is the difference between the Employment to population ratio(%) of High income: OECD and Employment to population ratio(%) of Bangladesh?
Provide a short and direct response. -20.14. In the year 1999, what is the difference between the Employment to population ratio(%) in High income: OECD and Employment to population ratio(%) in Congo (Democratic)?
Your answer should be compact. 9.16. In the year 1999, what is the difference between the Employment to population ratio(%) of High income: OECD and Employment to population ratio(%) of Portugal?
Provide a succinct answer. 0.06. In the year 1999, what is the difference between the Employment to population ratio(%) in Bangladesh and Employment to population ratio(%) in Congo (Democratic)?
Offer a terse response. 29.3. In the year 1999, what is the difference between the Employment to population ratio(%) in Bangladesh and Employment to population ratio(%) in Portugal?
Your answer should be very brief. 20.2. In the year 2000, what is the difference between the Employment to population ratio(%) in High income: OECD and Employment to population ratio(%) in Bangladesh?
Provide a short and direct response. -18.43. In the year 2000, what is the difference between the Employment to population ratio(%) in High income: OECD and Employment to population ratio(%) in Congo (Democratic)?
Offer a very short reply. 9.77. In the year 2000, what is the difference between the Employment to population ratio(%) in High income: OECD and Employment to population ratio(%) in Portugal?
Your answer should be very brief. -0.43. In the year 2000, what is the difference between the Employment to population ratio(%) of Bangladesh and Employment to population ratio(%) of Congo (Democratic)?
Provide a short and direct response. 28.2. In the year 2001, what is the difference between the Employment to population ratio(%) of High income: OECD and Employment to population ratio(%) of Bangladesh?
Provide a succinct answer. -19.37. In the year 2001, what is the difference between the Employment to population ratio(%) in High income: OECD and Employment to population ratio(%) in Congo (Democratic)?
Provide a short and direct response. 8.73. In the year 2001, what is the difference between the Employment to population ratio(%) in High income: OECD and Employment to population ratio(%) in Portugal?
Your answer should be very brief. -2.27. In the year 2001, what is the difference between the Employment to population ratio(%) of Bangladesh and Employment to population ratio(%) of Congo (Democratic)?
Keep it short and to the point. 28.1. In the year 2002, what is the difference between the Employment to population ratio(%) in High income: OECD and Employment to population ratio(%) in Bangladesh?
Provide a short and direct response. -20.51. In the year 2002, what is the difference between the Employment to population ratio(%) in High income: OECD and Employment to population ratio(%) in Congo (Democratic)?
Offer a very short reply. 7.49. In the year 2002, what is the difference between the Employment to population ratio(%) in High income: OECD and Employment to population ratio(%) in Portugal?
Your response must be concise. -2.71. In the year 2003, what is the difference between the Employment to population ratio(%) of High income: OECD and Employment to population ratio(%) of Bangladesh?
Give a very brief answer. -22.54. In the year 2003, what is the difference between the Employment to population ratio(%) in High income: OECD and Employment to population ratio(%) in Congo (Democratic)?
Give a very brief answer. 6.56. In the year 2003, what is the difference between the Employment to population ratio(%) of High income: OECD and Employment to population ratio(%) of Portugal?
Offer a very short reply. 1.06. In the year 2003, what is the difference between the Employment to population ratio(%) in Bangladesh and Employment to population ratio(%) in Congo (Democratic)?
Give a very brief answer. 29.1. In the year 2003, what is the difference between the Employment to population ratio(%) in Bangladesh and Employment to population ratio(%) in Portugal?
Offer a terse response. 23.6. In the year 2004, what is the difference between the Employment to population ratio(%) of High income: OECD and Employment to population ratio(%) of Bangladesh?
Provide a short and direct response. -21.65. In the year 2004, what is the difference between the Employment to population ratio(%) of High income: OECD and Employment to population ratio(%) of Congo (Democratic)?
Keep it short and to the point. 6.85. In the year 2004, what is the difference between the Employment to population ratio(%) of High income: OECD and Employment to population ratio(%) of Portugal?
Give a very brief answer. 2.65. In the year 2004, what is the difference between the Employment to population ratio(%) of Bangladesh and Employment to population ratio(%) of Congo (Democratic)?
Provide a short and direct response. 28.5. In the year 2004, what is the difference between the Employment to population ratio(%) of Bangladesh and Employment to population ratio(%) of Portugal?
Ensure brevity in your answer.  24.3. In the year 2004, what is the difference between the Employment to population ratio(%) of Congo (Democratic) and Employment to population ratio(%) of Portugal?
Give a very brief answer. -4.2. What is the ratio of the Employment to population ratio(%) of High income: OECD in 1997 to that in 1998?
Provide a succinct answer. 1. What is the ratio of the Employment to population ratio(%) in Bangladesh in 1997 to that in 1998?
Keep it short and to the point. 1. What is the ratio of the Employment to population ratio(%) of Portugal in 1997 to that in 1998?
Your response must be concise. 0.93. What is the ratio of the Employment to population ratio(%) of Bangladesh in 1997 to that in 1999?
Make the answer very short. 1.03. What is the ratio of the Employment to population ratio(%) in Congo (Democratic) in 1997 to that in 1999?
Ensure brevity in your answer.  1. What is the ratio of the Employment to population ratio(%) in Portugal in 1997 to that in 1999?
Your answer should be compact. 0.92. What is the ratio of the Employment to population ratio(%) in High income: OECD in 1997 to that in 2000?
Make the answer very short. 0.99. What is the ratio of the Employment to population ratio(%) of Bangladesh in 1997 to that in 2000?
Keep it short and to the point. 1.04. What is the ratio of the Employment to population ratio(%) of Portugal in 1997 to that in 2000?
Give a very brief answer. 0.9. What is the ratio of the Employment to population ratio(%) of High income: OECD in 1997 to that in 2001?
Keep it short and to the point. 1.01. What is the ratio of the Employment to population ratio(%) in Bangladesh in 1997 to that in 2001?
Offer a very short reply. 1.05. What is the ratio of the Employment to population ratio(%) in Congo (Democratic) in 1997 to that in 2001?
Provide a short and direct response. 1.01. What is the ratio of the Employment to population ratio(%) of Portugal in 1997 to that in 2001?
Give a very brief answer. 0.88. What is the ratio of the Employment to population ratio(%) in High income: OECD in 1997 to that in 2002?
Your response must be concise. 1.04. What is the ratio of the Employment to population ratio(%) in Bangladesh in 1997 to that in 2002?
Keep it short and to the point. 1.05. What is the ratio of the Employment to population ratio(%) of Congo (Democratic) in 1997 to that in 2002?
Your response must be concise. 1.01. What is the ratio of the Employment to population ratio(%) in Portugal in 1997 to that in 2002?
Offer a very short reply. 0.9. What is the ratio of the Employment to population ratio(%) in High income: OECD in 1997 to that in 2003?
Keep it short and to the point. 1.07. What is the ratio of the Employment to population ratio(%) of Bangladesh in 1997 to that in 2003?
Give a very brief answer. 1.03. What is the ratio of the Employment to population ratio(%) of High income: OECD in 1997 to that in 2004?
Give a very brief answer. 1.06. What is the ratio of the Employment to population ratio(%) of Bangladesh in 1997 to that in 2004?
Offer a very short reply. 1.04. What is the ratio of the Employment to population ratio(%) in Congo (Democratic) in 1997 to that in 2004?
Ensure brevity in your answer.  1.01. What is the ratio of the Employment to population ratio(%) in Portugal in 1997 to that in 2004?
Provide a succinct answer. 1.03. What is the ratio of the Employment to population ratio(%) of Bangladesh in 1998 to that in 1999?
Your answer should be compact. 1.03. What is the ratio of the Employment to population ratio(%) of Congo (Democratic) in 1998 to that in 1999?
Offer a very short reply. 1. What is the ratio of the Employment to population ratio(%) of High income: OECD in 1998 to that in 2000?
Ensure brevity in your answer.  0.99. What is the ratio of the Employment to population ratio(%) in Bangladesh in 1998 to that in 2000?
Give a very brief answer. 1.05. What is the ratio of the Employment to population ratio(%) of Portugal in 1998 to that in 2000?
Ensure brevity in your answer.  0.97. What is the ratio of the Employment to population ratio(%) of High income: OECD in 1998 to that in 2001?
Keep it short and to the point. 1.01. What is the ratio of the Employment to population ratio(%) of Bangladesh in 1998 to that in 2001?
Make the answer very short. 1.05. What is the ratio of the Employment to population ratio(%) in Congo (Democratic) in 1998 to that in 2001?
Your answer should be very brief. 1.01. What is the ratio of the Employment to population ratio(%) in Portugal in 1998 to that in 2001?
Your response must be concise. 0.95. What is the ratio of the Employment to population ratio(%) of High income: OECD in 1998 to that in 2002?
Offer a very short reply. 1.04. What is the ratio of the Employment to population ratio(%) of Bangladesh in 1998 to that in 2002?
Provide a succinct answer. 1.05. What is the ratio of the Employment to population ratio(%) of Congo (Democratic) in 1998 to that in 2002?
Your answer should be very brief. 1.01. What is the ratio of the Employment to population ratio(%) of Portugal in 1998 to that in 2002?
Provide a succinct answer. 0.97. What is the ratio of the Employment to population ratio(%) in High income: OECD in 1998 to that in 2003?
Offer a terse response. 1.07. What is the ratio of the Employment to population ratio(%) of Bangladesh in 1998 to that in 2003?
Keep it short and to the point. 1.04. What is the ratio of the Employment to population ratio(%) of Congo (Democratic) in 1998 to that in 2003?
Provide a short and direct response. 1.01. What is the ratio of the Employment to population ratio(%) in High income: OECD in 1998 to that in 2004?
Provide a short and direct response. 1.06. What is the ratio of the Employment to population ratio(%) in Bangladesh in 1998 to that in 2004?
Provide a short and direct response. 1.05. What is the ratio of the Employment to population ratio(%) of Congo (Democratic) in 1998 to that in 2004?
Offer a very short reply. 1.01. What is the ratio of the Employment to population ratio(%) in Portugal in 1998 to that in 2004?
Ensure brevity in your answer.  1.12. What is the ratio of the Employment to population ratio(%) of High income: OECD in 1999 to that in 2000?
Your answer should be very brief. 0.99. What is the ratio of the Employment to population ratio(%) in Bangladesh in 1999 to that in 2000?
Ensure brevity in your answer.  1.02. What is the ratio of the Employment to population ratio(%) of Congo (Democratic) in 1999 to that in 2000?
Give a very brief answer. 1. What is the ratio of the Employment to population ratio(%) in Portugal in 1999 to that in 2000?
Provide a short and direct response. 0.98. What is the ratio of the Employment to population ratio(%) in High income: OECD in 1999 to that in 2001?
Make the answer very short. 1.01. What is the ratio of the Employment to population ratio(%) in Bangladesh in 1999 to that in 2001?
Provide a short and direct response. 1.02. What is the ratio of the Employment to population ratio(%) in Congo (Democratic) in 1999 to that in 2001?
Offer a very short reply. 1. What is the ratio of the Employment to population ratio(%) of Portugal in 1999 to that in 2001?
Your response must be concise. 0.96. What is the ratio of the Employment to population ratio(%) in High income: OECD in 1999 to that in 2002?
Give a very brief answer. 1.04. What is the ratio of the Employment to population ratio(%) in Bangladesh in 1999 to that in 2002?
Make the answer very short. 1.02. What is the ratio of the Employment to population ratio(%) of Congo (Democratic) in 1999 to that in 2002?
Provide a short and direct response. 1. What is the ratio of the Employment to population ratio(%) in Portugal in 1999 to that in 2002?
Offer a very short reply. 0.98. What is the ratio of the Employment to population ratio(%) of High income: OECD in 1999 to that in 2003?
Keep it short and to the point. 1.06. What is the ratio of the Employment to population ratio(%) in Congo (Democratic) in 1999 to that in 2003?
Your answer should be very brief. 1.01. What is the ratio of the Employment to population ratio(%) of Portugal in 1999 to that in 2003?
Provide a succinct answer. 1.09. What is the ratio of the Employment to population ratio(%) in High income: OECD in 1999 to that in 2004?
Make the answer very short. 1.06. What is the ratio of the Employment to population ratio(%) of Bangladesh in 1999 to that in 2004?
Provide a short and direct response. 1.02. What is the ratio of the Employment to population ratio(%) in Congo (Democratic) in 1999 to that in 2004?
Your response must be concise. 1.01. What is the ratio of the Employment to population ratio(%) in Portugal in 1999 to that in 2004?
Your answer should be compact. 1.13. What is the ratio of the Employment to population ratio(%) in High income: OECD in 2000 to that in 2001?
Keep it short and to the point. 1.02. What is the ratio of the Employment to population ratio(%) of Bangladesh in 2000 to that in 2001?
Offer a very short reply. 1. What is the ratio of the Employment to population ratio(%) of Portugal in 2000 to that in 2001?
Your answer should be very brief. 0.99. What is the ratio of the Employment to population ratio(%) in High income: OECD in 2000 to that in 2002?
Provide a short and direct response. 1.05. What is the ratio of the Employment to population ratio(%) in Congo (Democratic) in 2000 to that in 2002?
Offer a terse response. 1. What is the ratio of the Employment to population ratio(%) of Portugal in 2000 to that in 2002?
Make the answer very short. 1. What is the ratio of the Employment to population ratio(%) of High income: OECD in 2000 to that in 2003?
Offer a terse response. 1.08. What is the ratio of the Employment to population ratio(%) in Bangladesh in 2000 to that in 2003?
Your response must be concise. 0.99. What is the ratio of the Employment to population ratio(%) of Congo (Democratic) in 2000 to that in 2003?
Give a very brief answer. 1.01. What is the ratio of the Employment to population ratio(%) in Portugal in 2000 to that in 2003?
Offer a terse response. 1.12. What is the ratio of the Employment to population ratio(%) of High income: OECD in 2000 to that in 2004?
Ensure brevity in your answer.  1.07. What is the ratio of the Employment to population ratio(%) of Congo (Democratic) in 2000 to that in 2004?
Provide a short and direct response. 1.01. What is the ratio of the Employment to population ratio(%) of Portugal in 2000 to that in 2004?
Offer a terse response. 1.15. What is the ratio of the Employment to population ratio(%) in High income: OECD in 2001 to that in 2002?
Offer a terse response. 1.03. What is the ratio of the Employment to population ratio(%) in Portugal in 2001 to that in 2002?
Your answer should be compact. 1.02. What is the ratio of the Employment to population ratio(%) in High income: OECD in 2001 to that in 2003?
Ensure brevity in your answer.  1.05. What is the ratio of the Employment to population ratio(%) in Bangladesh in 2001 to that in 2003?
Offer a very short reply. 0.99. What is the ratio of the Employment to population ratio(%) of Portugal in 2001 to that in 2003?
Offer a very short reply. 1.13. What is the ratio of the Employment to population ratio(%) of High income: OECD in 2001 to that in 2004?
Provide a short and direct response. 1.05. What is the ratio of the Employment to population ratio(%) in Bangladesh in 2001 to that in 2004?
Give a very brief answer. 1. What is the ratio of the Employment to population ratio(%) in Congo (Democratic) in 2001 to that in 2004?
Your answer should be compact. 1.01. What is the ratio of the Employment to population ratio(%) of Portugal in 2001 to that in 2004?
Provide a succinct answer. 1.17. What is the ratio of the Employment to population ratio(%) of High income: OECD in 2002 to that in 2003?
Your answer should be compact. 1.02. What is the ratio of the Employment to population ratio(%) in Bangladesh in 2002 to that in 2003?
Offer a terse response. 0.98. What is the ratio of the Employment to population ratio(%) of Portugal in 2002 to that in 2003?
Ensure brevity in your answer.  1.11. What is the ratio of the Employment to population ratio(%) in High income: OECD in 2002 to that in 2004?
Make the answer very short. 1.02. What is the ratio of the Employment to population ratio(%) in Bangladesh in 2002 to that in 2004?
Offer a very short reply. 1. What is the ratio of the Employment to population ratio(%) of Congo (Democratic) in 2002 to that in 2004?
Provide a succinct answer. 1.01. What is the ratio of the Employment to population ratio(%) in Portugal in 2002 to that in 2004?
Your answer should be very brief. 1.15. What is the ratio of the Employment to population ratio(%) of Bangladesh in 2003 to that in 2004?
Make the answer very short. 1.01. What is the ratio of the Employment to population ratio(%) of Portugal in 2003 to that in 2004?
Provide a short and direct response. 1.03. What is the difference between the highest and the second highest Employment to population ratio(%) of High income: OECD?
Ensure brevity in your answer.  0.46. What is the difference between the highest and the second highest Employment to population ratio(%) of Bangladesh?
Provide a short and direct response. 0.3. What is the difference between the highest and the second highest Employment to population ratio(%) in Congo (Democratic)?
Make the answer very short. 0. What is the difference between the highest and the lowest Employment to population ratio(%) of High income: OECD?
Make the answer very short. 3.4. What is the difference between the highest and the lowest Employment to population ratio(%) in Bangladesh?
Make the answer very short. 3.4. What is the difference between the highest and the lowest Employment to population ratio(%) of Congo (Democratic)?
Keep it short and to the point. 0.4. 